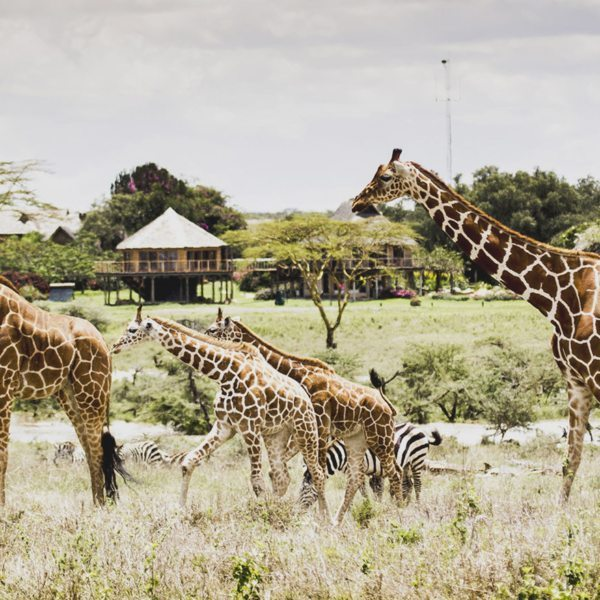What impact do these human-made structures have on the local wildlife and environment? The presence of human-made structures in wildlife areas can have both positive and negative impacts. On the positive side, eco-friendly lodges promote conservation awareness and provide economic support for local communities and wildlife protection programs. They allow for controlled tourism that can help fund preservation initiatives. However, if not carefully managed, these structures can disrupt local wildlife by introducing noise, light pollution, and human activity, potentially stressing the animals and altering their natural behaviors. The key is to design and manage these structures with sustainability in mind, ensuring they harmonize with the environment and support long-term conservation goals. 